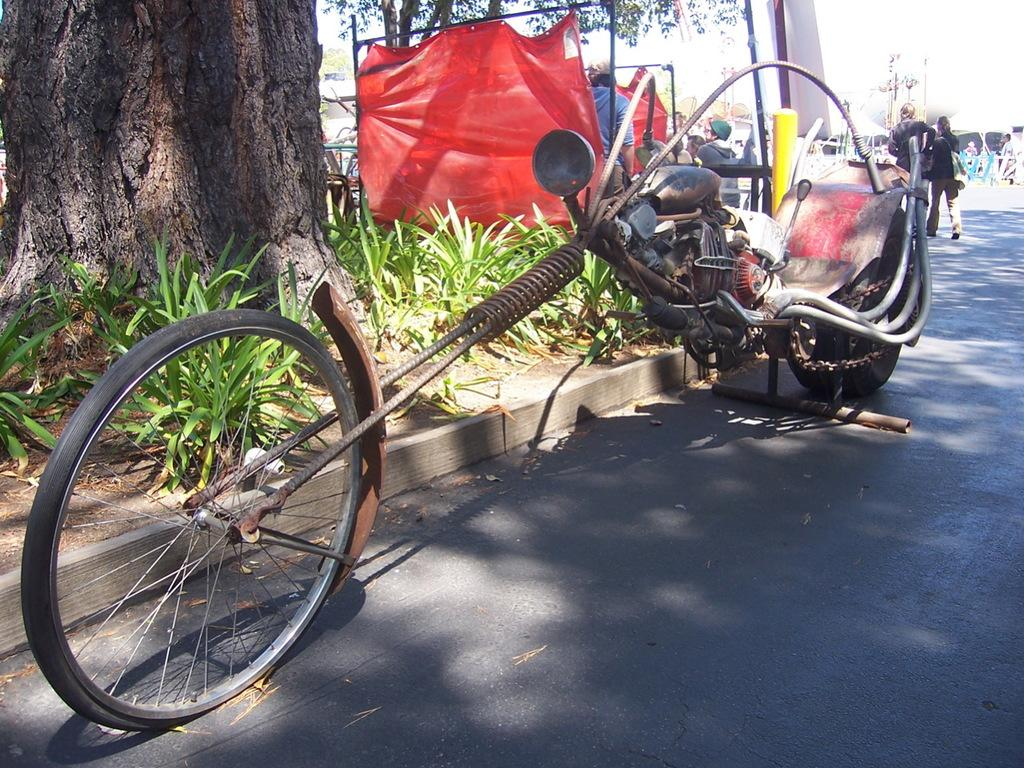What is parked on the road in the image? There is a vehicle parked on the road. What else can be seen on the road besides the parked vehicle? There are people walking on the road. What type of vegetation is visible beside the road? There are trees beside the road. What type of temporary shelter is set up beside the road? There is a tent beside the road. Where is the toothbrush stored in the image? There is no toothbrush present in the image. What type of stone can be seen in the image? There is no stone visible in the image. 